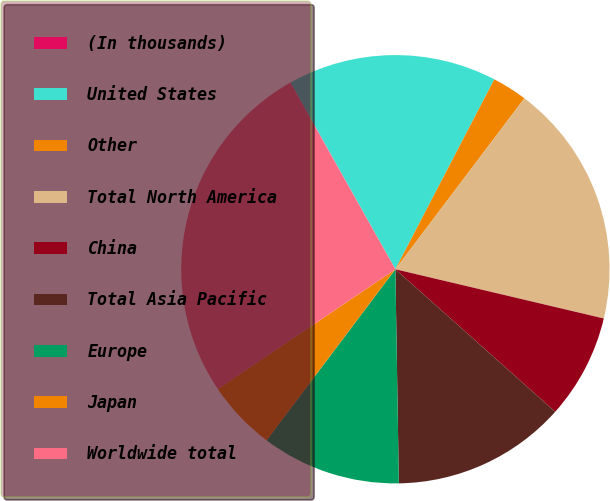Convert chart. <chart><loc_0><loc_0><loc_500><loc_500><pie_chart><fcel>(In thousands)<fcel>United States<fcel>Other<fcel>Total North America<fcel>China<fcel>Total Asia Pacific<fcel>Europe<fcel>Japan<fcel>Worldwide total<nl><fcel>0.03%<fcel>15.78%<fcel>2.65%<fcel>18.4%<fcel>7.9%<fcel>13.15%<fcel>10.53%<fcel>5.28%<fcel>26.28%<nl></chart> 